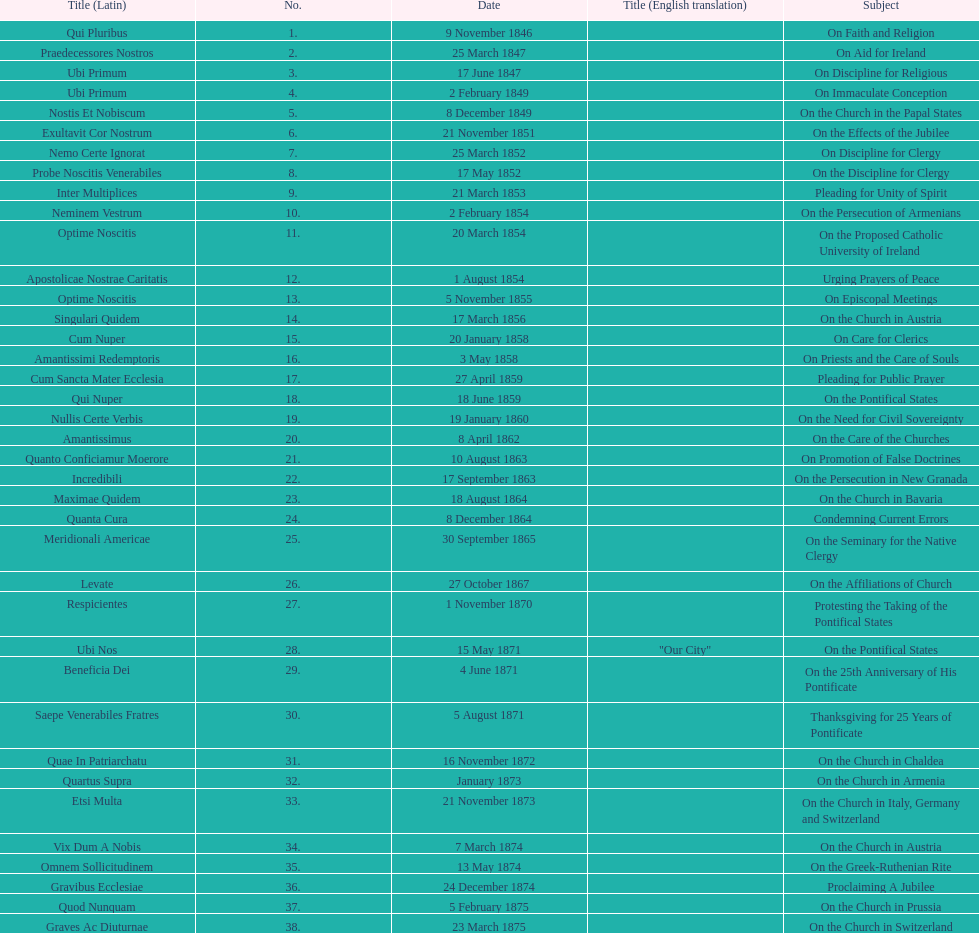Latin title of the encyclical before the encyclical with the subject "on the church in bavaria" Incredibili. 